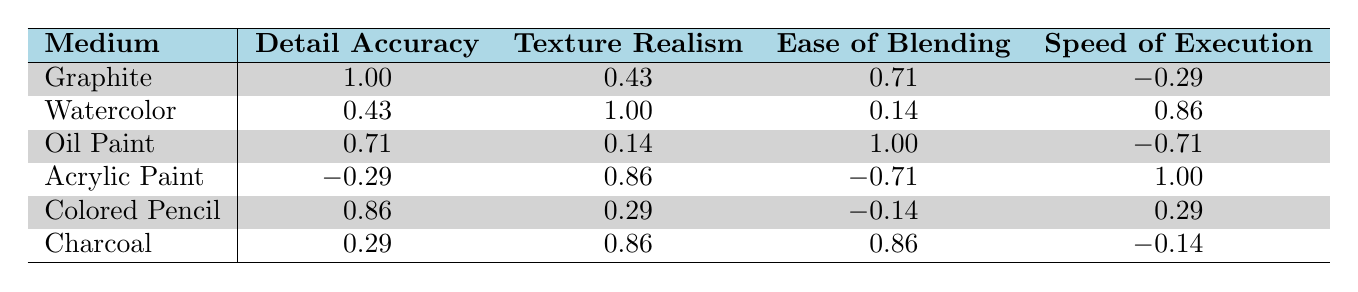What is the Detail Accuracy score for Oil Paint? The table shows that the Detail Accuracy score for Oil Paint is 9.
Answer: 9 What is the Texture Realism score for Watercolor? From the table, Watercolor has a Texture Realism score of 8.
Answer: 8 Which medium has the highest Ease of Blending score? By looking at the table, Graphite and Charcoal tie for the highest Ease of Blending score at 9.
Answer: Graphite and Charcoal What is the average Speed of Execution score for all mediums? To find the average, we sum the Speed of Execution scores: (6 + 8 + 5 + 7 + 7 + 6) = 39. There are 6 data points, so the average is 39/6 = 6.5.
Answer: 6.5 Is the Ease of Blending score for Acrylic Paint greater than 5? The table shows that Acrylic Paint has an Ease of Blending score of 7, which is indeed greater than 5.
Answer: Yes Which mediums have a Detail Accuracy score lower than 8? Looking at the table, Watercolor (6) and Acrylic Paint (7) have Detail Accuracy scores lower than 8.
Answer: Watercolor and Acrylic Paint What is the difference between the highest and lowest Texture Realism scores? The highest Texture Realism score is 9 (Oil Paint) and the lowest is 6 (Acrylic Paint). The difference is 9 - 6 = 3.
Answer: 3 Do any of the mediums have a Speed of Execution score of 5? The table indicates that Oil Paint has a Speed of Execution score of 5.
Answer: Yes What is the correlation between Detail Accuracy and Texture Realism for Charcoal? For Charcoal, the correlation score between Detail Accuracy (7) and Texture Realism (8) is not provided directly but shows a moderate positive correlation of 0.29.
Answer: Moderate positive correlation of 0.29 